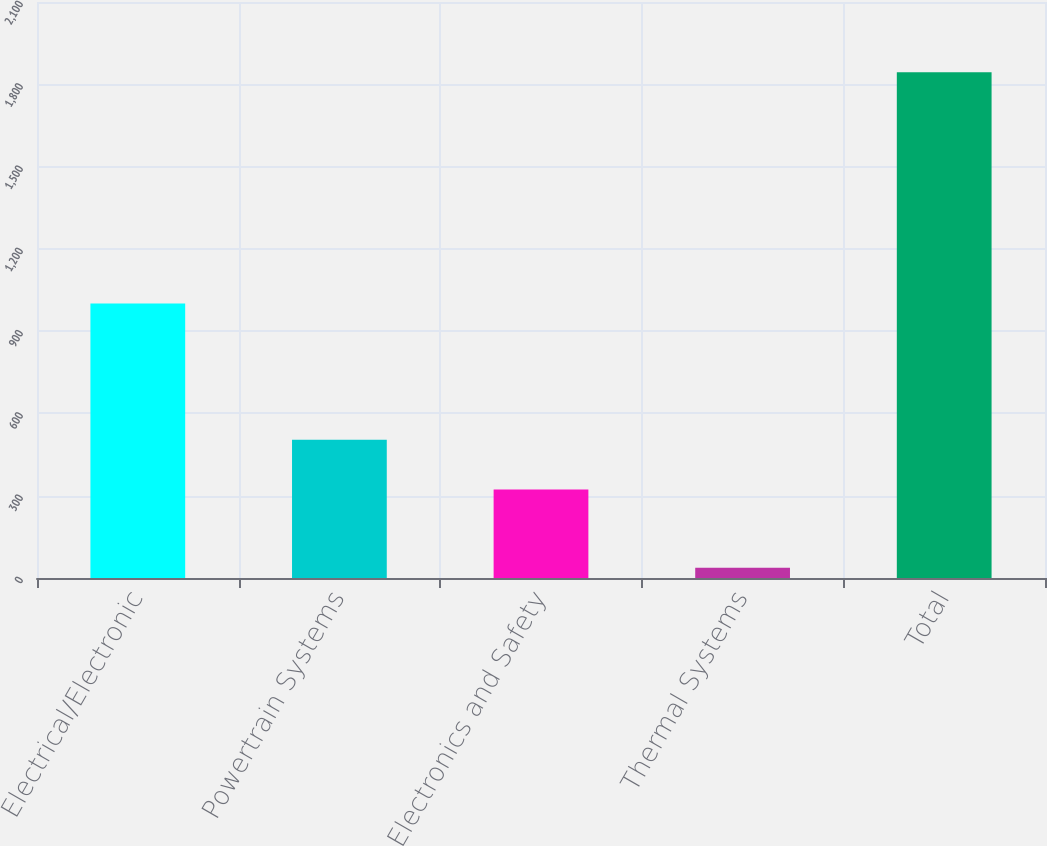Convert chart. <chart><loc_0><loc_0><loc_500><loc_500><bar_chart><fcel>Electrical/Electronic<fcel>Powertrain Systems<fcel>Electronics and Safety<fcel>Thermal Systems<fcel>Total<nl><fcel>1001<fcel>503.7<fcel>323<fcel>37<fcel>1844<nl></chart> 